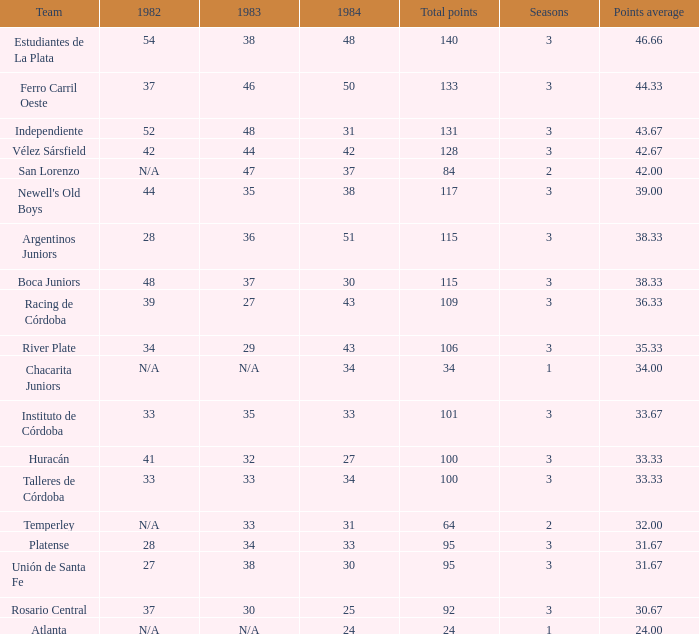What is the overall points for the team that has a points average greater than 34, a 1984 score of more than 37, and no data available for 1982? 0.0. 